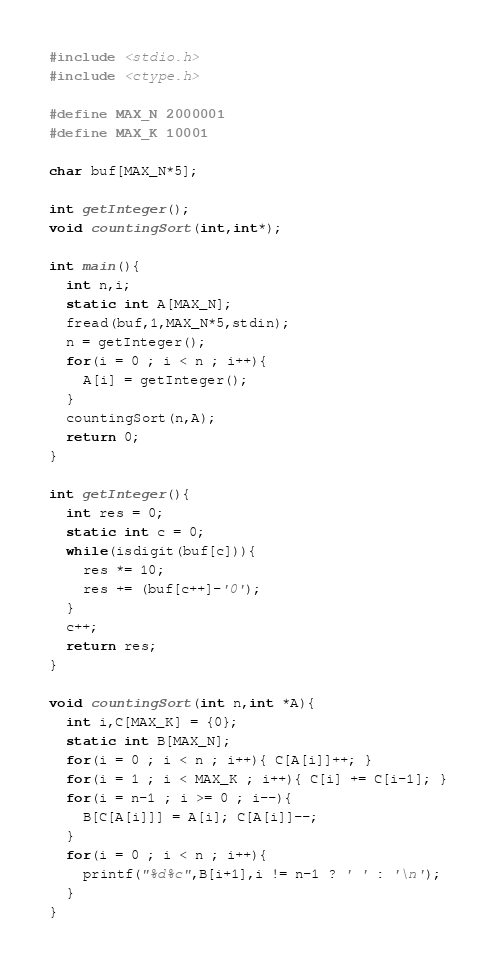Convert code to text. <code><loc_0><loc_0><loc_500><loc_500><_C_>#include <stdio.h>
#include <ctype.h>

#define MAX_N 2000001
#define MAX_K 10001

char buf[MAX_N*5];

int getInteger();
void countingSort(int,int*);

int main(){
  int n,i;
  static int A[MAX_N];
  fread(buf,1,MAX_N*5,stdin);
  n = getInteger();
  for(i = 0 ; i < n ; i++){
    A[i] = getInteger();
  }
  countingSort(n,A);
  return 0;
}

int getInteger(){
  int res = 0;
  static int c = 0;
  while(isdigit(buf[c])){
    res *= 10;
    res += (buf[c++]-'0');
  }
  c++;
  return res;
}

void countingSort(int n,int *A){
  int i,C[MAX_K] = {0};
  static int B[MAX_N];
  for(i = 0 ; i < n ; i++){ C[A[i]]++; }
  for(i = 1 ; i < MAX_K ; i++){ C[i] += C[i-1]; }
  for(i = n-1 ; i >= 0 ; i--){
    B[C[A[i]]] = A[i]; C[A[i]]--;
  }
  for(i = 0 ; i < n ; i++){
    printf("%d%c",B[i+1],i != n-1 ? ' ' : '\n');
  }
}</code> 